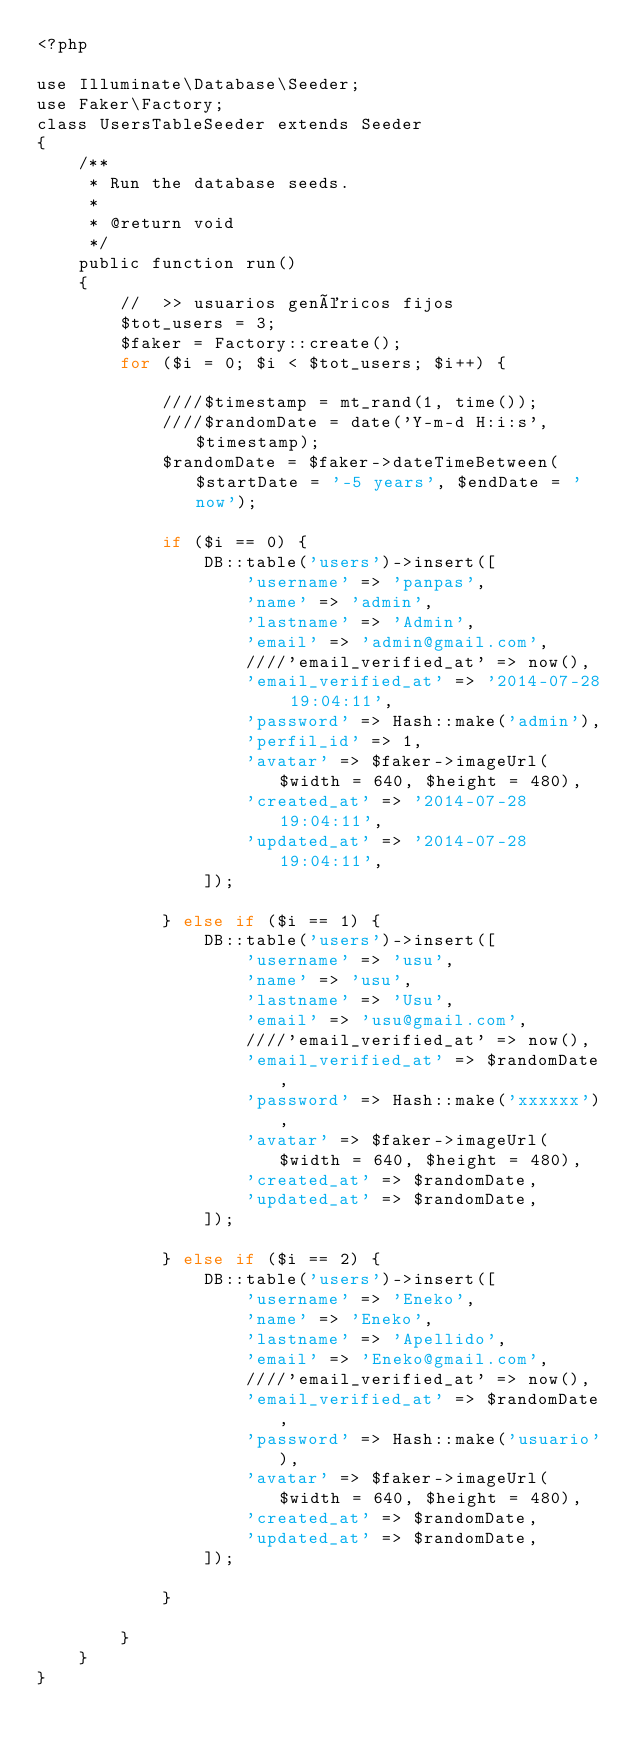<code> <loc_0><loc_0><loc_500><loc_500><_PHP_><?php

use Illuminate\Database\Seeder;
use Faker\Factory;
class UsersTableSeeder extends Seeder
{
    /**
     * Run the database seeds.
     *
     * @return void
     */
    public function run()
    {
        //  >> usuarios genéricos fijos
        $tot_users = 3;
        $faker = Factory::create();
        for ($i = 0; $i < $tot_users; $i++) {

            ////$timestamp = mt_rand(1, time());
            ////$randomDate = date('Y-m-d H:i:s', $timestamp);
            $randomDate = $faker->dateTimeBetween($startDate = '-5 years', $endDate = 'now');

            if ($i == 0) {
                DB::table('users')->insert([
                    'username' => 'panpas',
                    'name' => 'admin',
                    'lastname' => 'Admin',
                    'email' => 'admin@gmail.com',
                    ////'email_verified_at' => now(),
                    'email_verified_at' => '2014-07-28 19:04:11',
                    'password' => Hash::make('admin'),
                    'perfil_id' => 1,
                    'avatar' => $faker->imageUrl($width = 640, $height = 480),
                    'created_at' => '2014-07-28 19:04:11',
                    'updated_at' => '2014-07-28 19:04:11',
                ]);

            } else if ($i == 1) {
                DB::table('users')->insert([
                    'username' => 'usu',
                    'name' => 'usu',
                    'lastname' => 'Usu',
                    'email' => 'usu@gmail.com',
                    ////'email_verified_at' => now(),
                    'email_verified_at' => $randomDate,
                    'password' => Hash::make('xxxxxx'),
                    'avatar' => $faker->imageUrl($width = 640, $height = 480),
                    'created_at' => $randomDate,
                    'updated_at' => $randomDate,
                ]);

            } else if ($i == 2) {
                DB::table('users')->insert([
                    'username' => 'Eneko',
                    'name' => 'Eneko',
                    'lastname' => 'Apellido',
                    'email' => 'Eneko@gmail.com',
                    ////'email_verified_at' => now(),
                    'email_verified_at' => $randomDate,
                    'password' => Hash::make('usuario'),
                    'avatar' => $faker->imageUrl($width = 640, $height = 480),
                    'created_at' => $randomDate,
                    'updated_at' => $randomDate,
                ]);

            }

        }
    }
}
</code> 